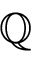<formula> <loc_0><loc_0><loc_500><loc_500>\mathbb { Q }</formula> 